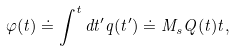<formula> <loc_0><loc_0><loc_500><loc_500>\varphi ( t ) \doteq \int ^ { t } d t ^ { \prime } q ( t ^ { \prime } ) \doteq M _ { s } Q ( t ) t ,</formula> 